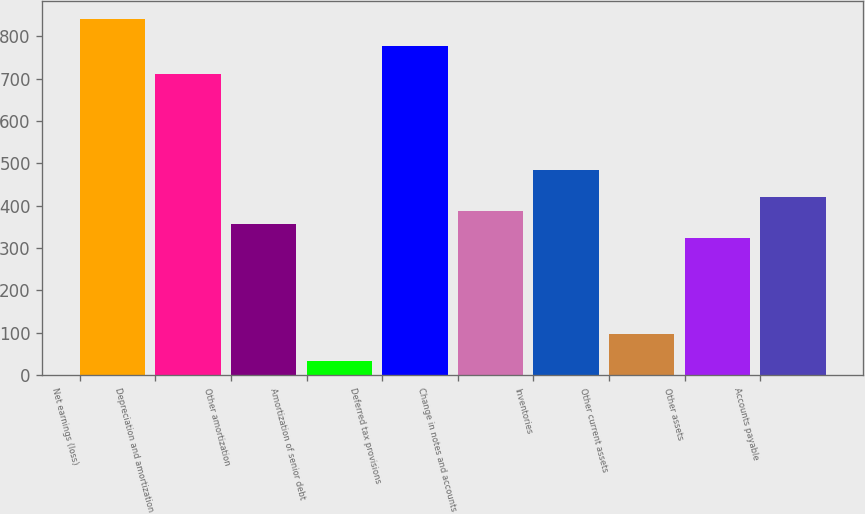Convert chart. <chart><loc_0><loc_0><loc_500><loc_500><bar_chart><fcel>Net earnings (loss)<fcel>Depreciation and amortization<fcel>Other amortization<fcel>Amortization of senior debt<fcel>Deferred tax provisions<fcel>Change in notes and accounts<fcel>Inventories<fcel>Other current assets<fcel>Other assets<fcel>Accounts payable<nl><fcel>840.86<fcel>711.62<fcel>356.21<fcel>33.11<fcel>776.24<fcel>388.52<fcel>485.45<fcel>97.73<fcel>323.9<fcel>420.83<nl></chart> 